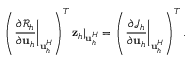<formula> <loc_0><loc_0><loc_500><loc_500>\left ( \frac { \partial \mathcal { R } _ { h } } { \partial u _ { h } } \right | _ { u _ { h } ^ { H } } \right ) ^ { T } z _ { h } | _ { u _ { h } ^ { H } } = \left ( \frac { \partial \mathcal { J } _ { h } } { \partial u _ { h } } \right | _ { u _ { h } ^ { H } } \right ) ^ { T } .</formula> 